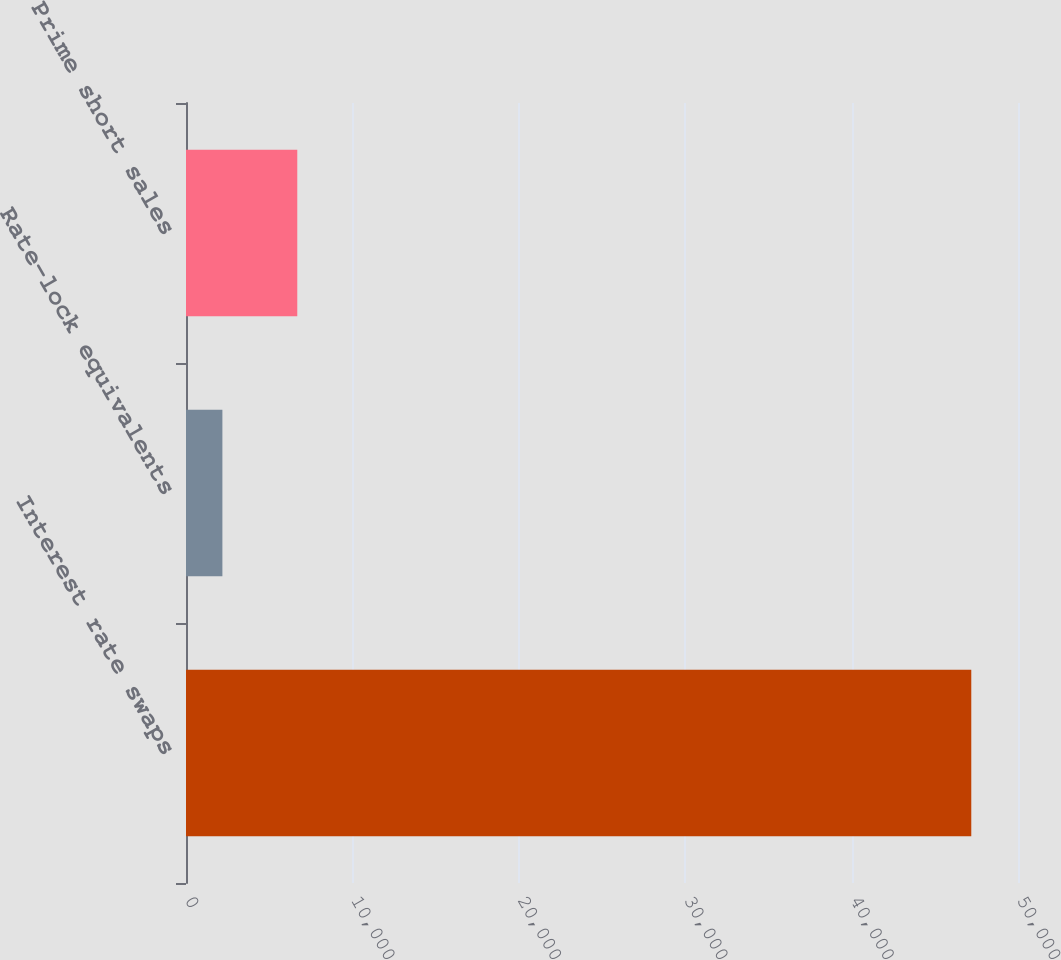Convert chart to OTSL. <chart><loc_0><loc_0><loc_500><loc_500><bar_chart><fcel>Interest rate swaps<fcel>Rate-lock equivalents<fcel>Prime short sales<nl><fcel>47192<fcel>2187<fcel>6687.5<nl></chart> 